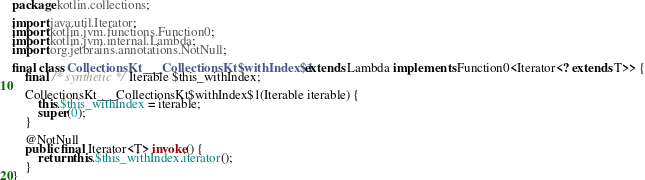<code> <loc_0><loc_0><loc_500><loc_500><_Java_>package kotlin.collections;

import java.util.Iterator;
import kotlin.jvm.functions.Function0;
import kotlin.jvm.internal.Lambda;
import org.jetbrains.annotations.NotNull;

final class CollectionsKt___CollectionsKt$withIndex$1 extends Lambda implements Function0<Iterator<? extends T>> {
    final /* synthetic */ Iterable $this_withIndex;

    CollectionsKt___CollectionsKt$withIndex$1(Iterable iterable) {
        this.$this_withIndex = iterable;
        super(0);
    }

    @NotNull
    public final Iterator<T> invoke() {
        return this.$this_withIndex.iterator();
    }
}
</code> 